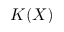<formula> <loc_0><loc_0><loc_500><loc_500>K ( X )</formula> 